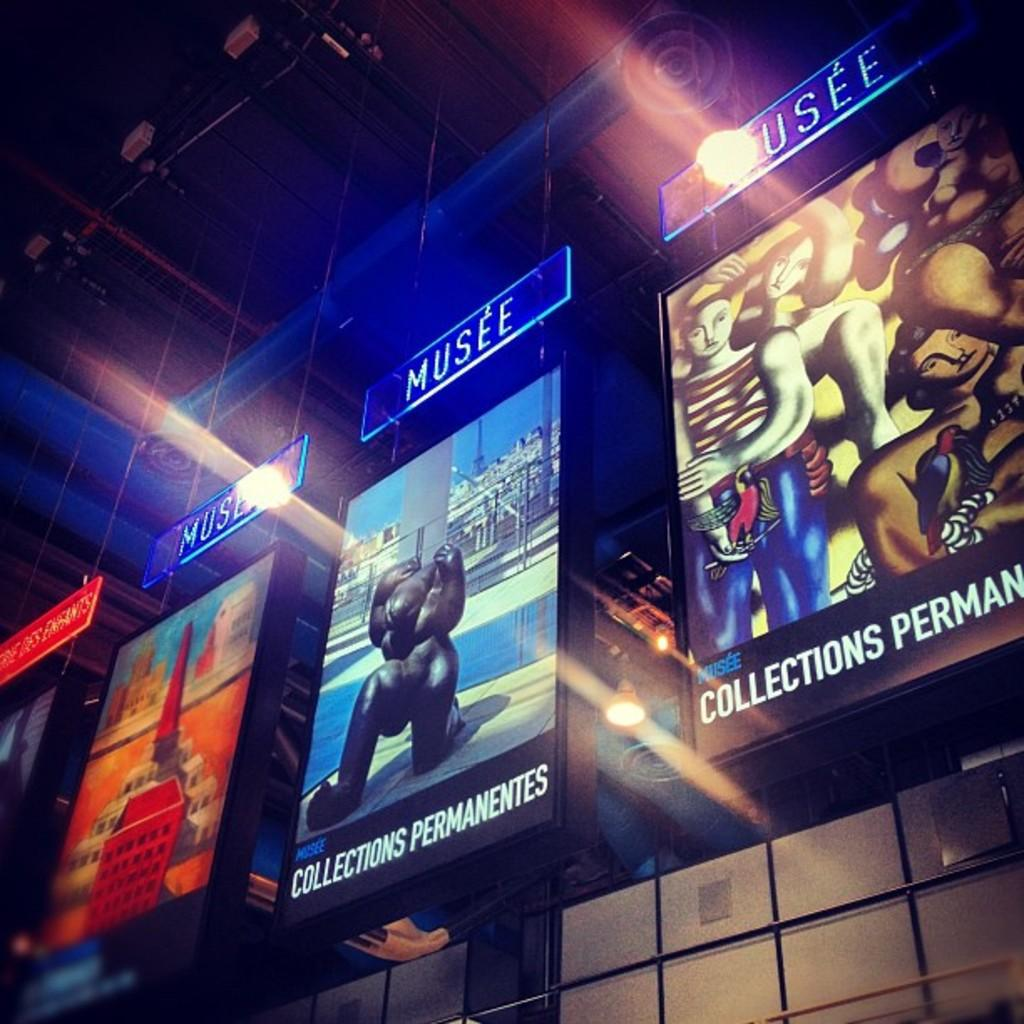<image>
Create a compact narrative representing the image presented. three pictures next to one another with the titles 'musee' 